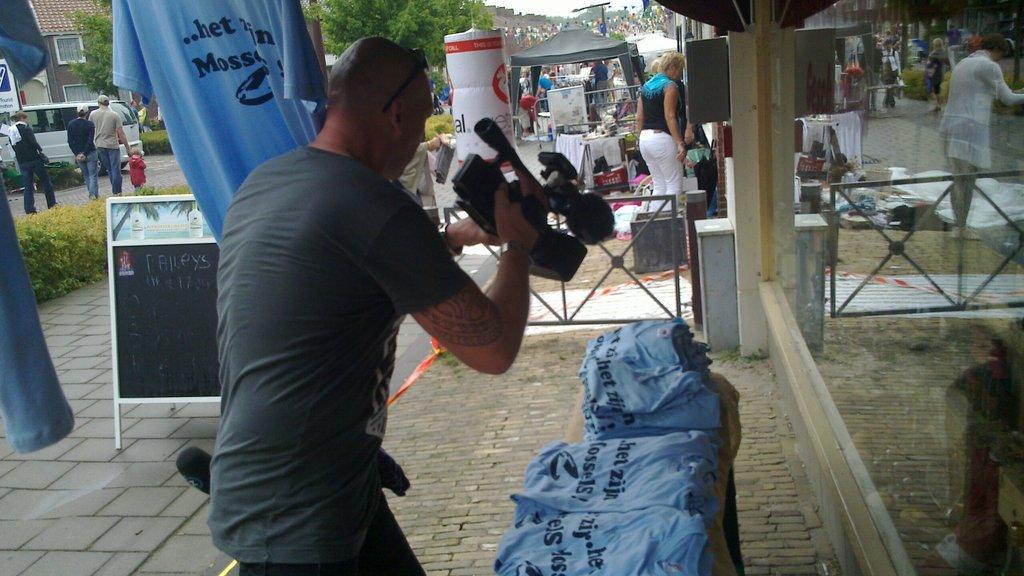Could you give a brief overview of what you see in this image? In this image, we can see persons wearing clothes. There is a person in the middle of the image holding a camera with his hand. There are bags at the bottom of the image. There is a window on the right side of the image. On the left side of the image, we can see vehicles, plants and board. There is a t-shirt in the top left of the image. There is a tent and tree at the top of the image. 